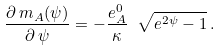Convert formula to latex. <formula><loc_0><loc_0><loc_500><loc_500>\frac { \partial \, m _ { A } ( \psi ) } { \partial \, \psi } = - \frac { e _ { A } ^ { 0 } } { \kappa } \ \sqrt { e ^ { 2 \psi } - 1 } \, .</formula> 